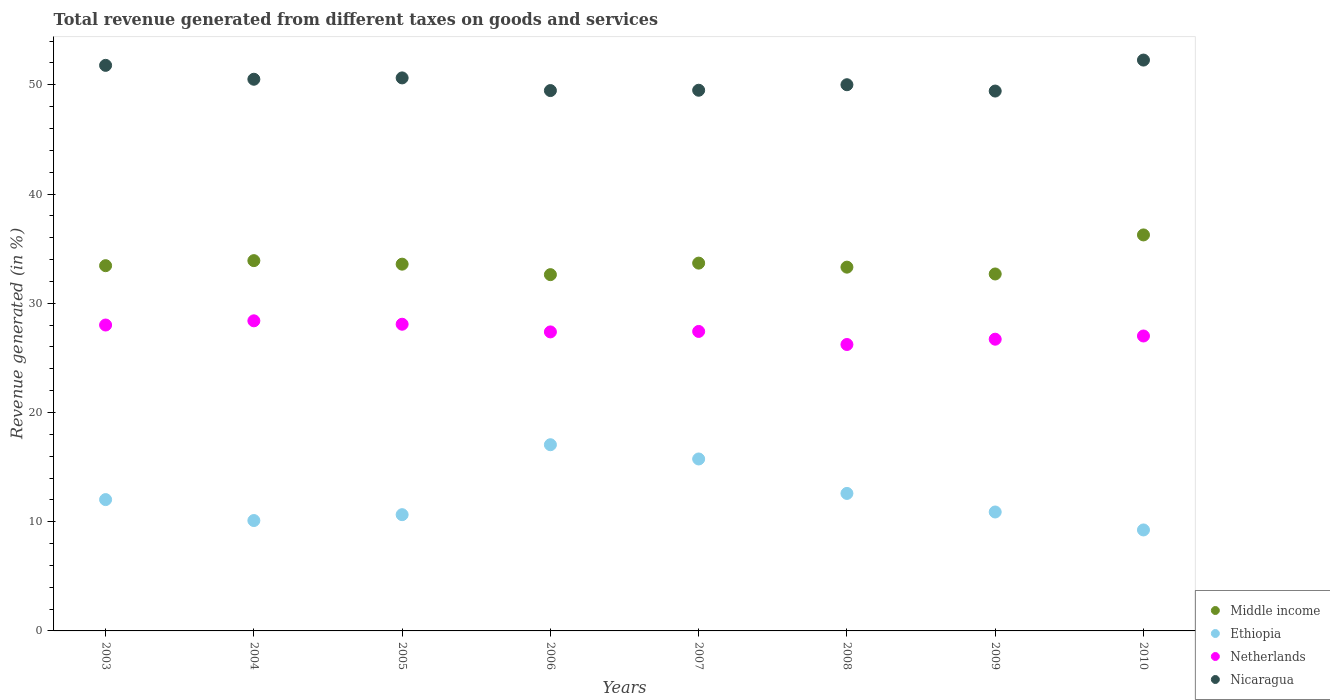Is the number of dotlines equal to the number of legend labels?
Your response must be concise. Yes. What is the total revenue generated in Middle income in 2006?
Your response must be concise. 32.62. Across all years, what is the maximum total revenue generated in Netherlands?
Make the answer very short. 28.39. Across all years, what is the minimum total revenue generated in Middle income?
Keep it short and to the point. 32.62. What is the total total revenue generated in Ethiopia in the graph?
Provide a succinct answer. 98.29. What is the difference between the total revenue generated in Ethiopia in 2003 and that in 2007?
Ensure brevity in your answer.  -3.72. What is the difference between the total revenue generated in Ethiopia in 2003 and the total revenue generated in Netherlands in 2009?
Provide a succinct answer. -14.69. What is the average total revenue generated in Nicaragua per year?
Ensure brevity in your answer.  50.45. In the year 2006, what is the difference between the total revenue generated in Ethiopia and total revenue generated in Middle income?
Offer a terse response. -15.57. What is the ratio of the total revenue generated in Middle income in 2007 to that in 2010?
Your answer should be very brief. 0.93. Is the total revenue generated in Nicaragua in 2004 less than that in 2009?
Provide a succinct answer. No. What is the difference between the highest and the second highest total revenue generated in Ethiopia?
Your response must be concise. 1.3. What is the difference between the highest and the lowest total revenue generated in Ethiopia?
Your answer should be very brief. 7.8. Is it the case that in every year, the sum of the total revenue generated in Ethiopia and total revenue generated in Netherlands  is greater than the sum of total revenue generated in Middle income and total revenue generated in Nicaragua?
Offer a very short reply. No. Is it the case that in every year, the sum of the total revenue generated in Netherlands and total revenue generated in Middle income  is greater than the total revenue generated in Ethiopia?
Make the answer very short. Yes. Is the total revenue generated in Ethiopia strictly greater than the total revenue generated in Middle income over the years?
Provide a short and direct response. No. How many dotlines are there?
Your response must be concise. 4. What is the difference between two consecutive major ticks on the Y-axis?
Give a very brief answer. 10. Does the graph contain any zero values?
Make the answer very short. No. Does the graph contain grids?
Provide a short and direct response. No. Where does the legend appear in the graph?
Offer a very short reply. Bottom right. How many legend labels are there?
Offer a terse response. 4. How are the legend labels stacked?
Offer a terse response. Vertical. What is the title of the graph?
Give a very brief answer. Total revenue generated from different taxes on goods and services. Does "Rwanda" appear as one of the legend labels in the graph?
Offer a very short reply. No. What is the label or title of the X-axis?
Your answer should be very brief. Years. What is the label or title of the Y-axis?
Your answer should be compact. Revenue generated (in %). What is the Revenue generated (in %) of Middle income in 2003?
Keep it short and to the point. 33.44. What is the Revenue generated (in %) of Ethiopia in 2003?
Give a very brief answer. 12.02. What is the Revenue generated (in %) of Netherlands in 2003?
Keep it short and to the point. 28.01. What is the Revenue generated (in %) of Nicaragua in 2003?
Your answer should be compact. 51.78. What is the Revenue generated (in %) in Middle income in 2004?
Make the answer very short. 33.9. What is the Revenue generated (in %) in Ethiopia in 2004?
Provide a short and direct response. 10.11. What is the Revenue generated (in %) of Netherlands in 2004?
Your answer should be compact. 28.39. What is the Revenue generated (in %) of Nicaragua in 2004?
Keep it short and to the point. 50.51. What is the Revenue generated (in %) in Middle income in 2005?
Your answer should be compact. 33.58. What is the Revenue generated (in %) of Ethiopia in 2005?
Offer a very short reply. 10.64. What is the Revenue generated (in %) of Netherlands in 2005?
Ensure brevity in your answer.  28.08. What is the Revenue generated (in %) in Nicaragua in 2005?
Offer a terse response. 50.63. What is the Revenue generated (in %) of Middle income in 2006?
Keep it short and to the point. 32.62. What is the Revenue generated (in %) of Ethiopia in 2006?
Your answer should be compact. 17.05. What is the Revenue generated (in %) of Netherlands in 2006?
Your response must be concise. 27.38. What is the Revenue generated (in %) in Nicaragua in 2006?
Give a very brief answer. 49.47. What is the Revenue generated (in %) of Middle income in 2007?
Your answer should be very brief. 33.68. What is the Revenue generated (in %) of Ethiopia in 2007?
Provide a short and direct response. 15.74. What is the Revenue generated (in %) in Netherlands in 2007?
Offer a terse response. 27.42. What is the Revenue generated (in %) of Nicaragua in 2007?
Provide a short and direct response. 49.5. What is the Revenue generated (in %) in Middle income in 2008?
Provide a short and direct response. 33.31. What is the Revenue generated (in %) of Ethiopia in 2008?
Keep it short and to the point. 12.59. What is the Revenue generated (in %) in Netherlands in 2008?
Make the answer very short. 26.22. What is the Revenue generated (in %) of Nicaragua in 2008?
Your response must be concise. 50.01. What is the Revenue generated (in %) of Middle income in 2009?
Offer a terse response. 32.68. What is the Revenue generated (in %) of Ethiopia in 2009?
Provide a succinct answer. 10.89. What is the Revenue generated (in %) of Netherlands in 2009?
Keep it short and to the point. 26.71. What is the Revenue generated (in %) in Nicaragua in 2009?
Keep it short and to the point. 49.43. What is the Revenue generated (in %) in Middle income in 2010?
Offer a terse response. 36.26. What is the Revenue generated (in %) in Ethiopia in 2010?
Your answer should be very brief. 9.25. What is the Revenue generated (in %) of Netherlands in 2010?
Your answer should be compact. 27. What is the Revenue generated (in %) of Nicaragua in 2010?
Provide a short and direct response. 52.27. Across all years, what is the maximum Revenue generated (in %) in Middle income?
Ensure brevity in your answer.  36.26. Across all years, what is the maximum Revenue generated (in %) in Ethiopia?
Your answer should be compact. 17.05. Across all years, what is the maximum Revenue generated (in %) in Netherlands?
Your response must be concise. 28.39. Across all years, what is the maximum Revenue generated (in %) in Nicaragua?
Keep it short and to the point. 52.27. Across all years, what is the minimum Revenue generated (in %) of Middle income?
Offer a terse response. 32.62. Across all years, what is the minimum Revenue generated (in %) in Ethiopia?
Keep it short and to the point. 9.25. Across all years, what is the minimum Revenue generated (in %) in Netherlands?
Your response must be concise. 26.22. Across all years, what is the minimum Revenue generated (in %) in Nicaragua?
Offer a terse response. 49.43. What is the total Revenue generated (in %) of Middle income in the graph?
Give a very brief answer. 269.47. What is the total Revenue generated (in %) in Ethiopia in the graph?
Your response must be concise. 98.29. What is the total Revenue generated (in %) of Netherlands in the graph?
Ensure brevity in your answer.  219.22. What is the total Revenue generated (in %) in Nicaragua in the graph?
Give a very brief answer. 403.61. What is the difference between the Revenue generated (in %) in Middle income in 2003 and that in 2004?
Your answer should be compact. -0.46. What is the difference between the Revenue generated (in %) of Ethiopia in 2003 and that in 2004?
Offer a terse response. 1.92. What is the difference between the Revenue generated (in %) in Netherlands in 2003 and that in 2004?
Provide a succinct answer. -0.39. What is the difference between the Revenue generated (in %) in Nicaragua in 2003 and that in 2004?
Give a very brief answer. 1.27. What is the difference between the Revenue generated (in %) of Middle income in 2003 and that in 2005?
Provide a succinct answer. -0.14. What is the difference between the Revenue generated (in %) of Ethiopia in 2003 and that in 2005?
Make the answer very short. 1.38. What is the difference between the Revenue generated (in %) in Netherlands in 2003 and that in 2005?
Your answer should be very brief. -0.07. What is the difference between the Revenue generated (in %) of Nicaragua in 2003 and that in 2005?
Your response must be concise. 1.15. What is the difference between the Revenue generated (in %) of Middle income in 2003 and that in 2006?
Ensure brevity in your answer.  0.82. What is the difference between the Revenue generated (in %) in Ethiopia in 2003 and that in 2006?
Give a very brief answer. -5.02. What is the difference between the Revenue generated (in %) of Netherlands in 2003 and that in 2006?
Offer a terse response. 0.63. What is the difference between the Revenue generated (in %) in Nicaragua in 2003 and that in 2006?
Give a very brief answer. 2.31. What is the difference between the Revenue generated (in %) in Middle income in 2003 and that in 2007?
Your response must be concise. -0.23. What is the difference between the Revenue generated (in %) in Ethiopia in 2003 and that in 2007?
Keep it short and to the point. -3.72. What is the difference between the Revenue generated (in %) of Netherlands in 2003 and that in 2007?
Your answer should be very brief. 0.59. What is the difference between the Revenue generated (in %) of Nicaragua in 2003 and that in 2007?
Keep it short and to the point. 2.28. What is the difference between the Revenue generated (in %) of Middle income in 2003 and that in 2008?
Make the answer very short. 0.13. What is the difference between the Revenue generated (in %) in Ethiopia in 2003 and that in 2008?
Offer a very short reply. -0.57. What is the difference between the Revenue generated (in %) of Netherlands in 2003 and that in 2008?
Your answer should be very brief. 1.78. What is the difference between the Revenue generated (in %) in Nicaragua in 2003 and that in 2008?
Offer a very short reply. 1.77. What is the difference between the Revenue generated (in %) in Middle income in 2003 and that in 2009?
Make the answer very short. 0.76. What is the difference between the Revenue generated (in %) of Ethiopia in 2003 and that in 2009?
Make the answer very short. 1.13. What is the difference between the Revenue generated (in %) of Netherlands in 2003 and that in 2009?
Offer a very short reply. 1.3. What is the difference between the Revenue generated (in %) of Nicaragua in 2003 and that in 2009?
Provide a short and direct response. 2.35. What is the difference between the Revenue generated (in %) of Middle income in 2003 and that in 2010?
Keep it short and to the point. -2.82. What is the difference between the Revenue generated (in %) in Ethiopia in 2003 and that in 2010?
Offer a terse response. 2.78. What is the difference between the Revenue generated (in %) of Netherlands in 2003 and that in 2010?
Give a very brief answer. 1. What is the difference between the Revenue generated (in %) of Nicaragua in 2003 and that in 2010?
Your answer should be compact. -0.48. What is the difference between the Revenue generated (in %) in Middle income in 2004 and that in 2005?
Offer a very short reply. 0.32. What is the difference between the Revenue generated (in %) of Ethiopia in 2004 and that in 2005?
Your response must be concise. -0.54. What is the difference between the Revenue generated (in %) of Netherlands in 2004 and that in 2005?
Ensure brevity in your answer.  0.31. What is the difference between the Revenue generated (in %) in Nicaragua in 2004 and that in 2005?
Make the answer very short. -0.12. What is the difference between the Revenue generated (in %) of Middle income in 2004 and that in 2006?
Offer a very short reply. 1.28. What is the difference between the Revenue generated (in %) of Ethiopia in 2004 and that in 2006?
Offer a very short reply. -6.94. What is the difference between the Revenue generated (in %) in Netherlands in 2004 and that in 2006?
Provide a succinct answer. 1.02. What is the difference between the Revenue generated (in %) in Nicaragua in 2004 and that in 2006?
Your answer should be very brief. 1.04. What is the difference between the Revenue generated (in %) in Middle income in 2004 and that in 2007?
Your response must be concise. 0.23. What is the difference between the Revenue generated (in %) of Ethiopia in 2004 and that in 2007?
Ensure brevity in your answer.  -5.64. What is the difference between the Revenue generated (in %) in Netherlands in 2004 and that in 2007?
Give a very brief answer. 0.97. What is the difference between the Revenue generated (in %) in Middle income in 2004 and that in 2008?
Offer a very short reply. 0.6. What is the difference between the Revenue generated (in %) in Ethiopia in 2004 and that in 2008?
Offer a very short reply. -2.48. What is the difference between the Revenue generated (in %) of Netherlands in 2004 and that in 2008?
Your response must be concise. 2.17. What is the difference between the Revenue generated (in %) in Nicaragua in 2004 and that in 2008?
Your answer should be very brief. 0.5. What is the difference between the Revenue generated (in %) of Middle income in 2004 and that in 2009?
Your answer should be very brief. 1.22. What is the difference between the Revenue generated (in %) of Ethiopia in 2004 and that in 2009?
Make the answer very short. -0.78. What is the difference between the Revenue generated (in %) in Netherlands in 2004 and that in 2009?
Ensure brevity in your answer.  1.68. What is the difference between the Revenue generated (in %) in Nicaragua in 2004 and that in 2009?
Your answer should be compact. 1.08. What is the difference between the Revenue generated (in %) in Middle income in 2004 and that in 2010?
Your response must be concise. -2.35. What is the difference between the Revenue generated (in %) of Ethiopia in 2004 and that in 2010?
Make the answer very short. 0.86. What is the difference between the Revenue generated (in %) of Netherlands in 2004 and that in 2010?
Provide a short and direct response. 1.39. What is the difference between the Revenue generated (in %) in Nicaragua in 2004 and that in 2010?
Give a very brief answer. -1.76. What is the difference between the Revenue generated (in %) in Middle income in 2005 and that in 2006?
Your answer should be compact. 0.96. What is the difference between the Revenue generated (in %) in Ethiopia in 2005 and that in 2006?
Offer a terse response. -6.4. What is the difference between the Revenue generated (in %) in Netherlands in 2005 and that in 2006?
Make the answer very short. 0.7. What is the difference between the Revenue generated (in %) in Nicaragua in 2005 and that in 2006?
Ensure brevity in your answer.  1.16. What is the difference between the Revenue generated (in %) of Middle income in 2005 and that in 2007?
Your response must be concise. -0.1. What is the difference between the Revenue generated (in %) of Ethiopia in 2005 and that in 2007?
Your answer should be very brief. -5.1. What is the difference between the Revenue generated (in %) in Netherlands in 2005 and that in 2007?
Offer a very short reply. 0.66. What is the difference between the Revenue generated (in %) in Nicaragua in 2005 and that in 2007?
Provide a succinct answer. 1.13. What is the difference between the Revenue generated (in %) of Middle income in 2005 and that in 2008?
Your response must be concise. 0.27. What is the difference between the Revenue generated (in %) of Ethiopia in 2005 and that in 2008?
Keep it short and to the point. -1.95. What is the difference between the Revenue generated (in %) of Netherlands in 2005 and that in 2008?
Provide a succinct answer. 1.86. What is the difference between the Revenue generated (in %) in Nicaragua in 2005 and that in 2008?
Your response must be concise. 0.62. What is the difference between the Revenue generated (in %) of Middle income in 2005 and that in 2009?
Offer a terse response. 0.9. What is the difference between the Revenue generated (in %) of Ethiopia in 2005 and that in 2009?
Your answer should be compact. -0.25. What is the difference between the Revenue generated (in %) in Netherlands in 2005 and that in 2009?
Give a very brief answer. 1.37. What is the difference between the Revenue generated (in %) of Nicaragua in 2005 and that in 2009?
Ensure brevity in your answer.  1.2. What is the difference between the Revenue generated (in %) in Middle income in 2005 and that in 2010?
Keep it short and to the point. -2.68. What is the difference between the Revenue generated (in %) in Ethiopia in 2005 and that in 2010?
Ensure brevity in your answer.  1.4. What is the difference between the Revenue generated (in %) of Netherlands in 2005 and that in 2010?
Provide a succinct answer. 1.08. What is the difference between the Revenue generated (in %) in Nicaragua in 2005 and that in 2010?
Your response must be concise. -1.63. What is the difference between the Revenue generated (in %) of Middle income in 2006 and that in 2007?
Offer a terse response. -1.06. What is the difference between the Revenue generated (in %) in Ethiopia in 2006 and that in 2007?
Provide a succinct answer. 1.3. What is the difference between the Revenue generated (in %) in Netherlands in 2006 and that in 2007?
Offer a very short reply. -0.04. What is the difference between the Revenue generated (in %) of Nicaragua in 2006 and that in 2007?
Give a very brief answer. -0.03. What is the difference between the Revenue generated (in %) in Middle income in 2006 and that in 2008?
Provide a succinct answer. -0.69. What is the difference between the Revenue generated (in %) of Ethiopia in 2006 and that in 2008?
Make the answer very short. 4.46. What is the difference between the Revenue generated (in %) of Netherlands in 2006 and that in 2008?
Your answer should be compact. 1.15. What is the difference between the Revenue generated (in %) of Nicaragua in 2006 and that in 2008?
Keep it short and to the point. -0.54. What is the difference between the Revenue generated (in %) in Middle income in 2006 and that in 2009?
Your response must be concise. -0.06. What is the difference between the Revenue generated (in %) in Ethiopia in 2006 and that in 2009?
Give a very brief answer. 6.16. What is the difference between the Revenue generated (in %) in Netherlands in 2006 and that in 2009?
Your answer should be compact. 0.67. What is the difference between the Revenue generated (in %) in Nicaragua in 2006 and that in 2009?
Offer a very short reply. 0.04. What is the difference between the Revenue generated (in %) of Middle income in 2006 and that in 2010?
Offer a very short reply. -3.64. What is the difference between the Revenue generated (in %) of Ethiopia in 2006 and that in 2010?
Provide a succinct answer. 7.8. What is the difference between the Revenue generated (in %) in Netherlands in 2006 and that in 2010?
Make the answer very short. 0.37. What is the difference between the Revenue generated (in %) of Nicaragua in 2006 and that in 2010?
Keep it short and to the point. -2.79. What is the difference between the Revenue generated (in %) in Middle income in 2007 and that in 2008?
Offer a very short reply. 0.37. What is the difference between the Revenue generated (in %) in Ethiopia in 2007 and that in 2008?
Your response must be concise. 3.15. What is the difference between the Revenue generated (in %) of Netherlands in 2007 and that in 2008?
Offer a very short reply. 1.2. What is the difference between the Revenue generated (in %) of Nicaragua in 2007 and that in 2008?
Give a very brief answer. -0.51. What is the difference between the Revenue generated (in %) in Middle income in 2007 and that in 2009?
Ensure brevity in your answer.  0.99. What is the difference between the Revenue generated (in %) in Ethiopia in 2007 and that in 2009?
Provide a succinct answer. 4.85. What is the difference between the Revenue generated (in %) in Netherlands in 2007 and that in 2009?
Provide a short and direct response. 0.71. What is the difference between the Revenue generated (in %) of Nicaragua in 2007 and that in 2009?
Your answer should be compact. 0.07. What is the difference between the Revenue generated (in %) in Middle income in 2007 and that in 2010?
Offer a very short reply. -2.58. What is the difference between the Revenue generated (in %) of Ethiopia in 2007 and that in 2010?
Provide a succinct answer. 6.5. What is the difference between the Revenue generated (in %) in Netherlands in 2007 and that in 2010?
Offer a terse response. 0.42. What is the difference between the Revenue generated (in %) of Nicaragua in 2007 and that in 2010?
Provide a succinct answer. -2.76. What is the difference between the Revenue generated (in %) of Middle income in 2008 and that in 2009?
Offer a very short reply. 0.63. What is the difference between the Revenue generated (in %) of Ethiopia in 2008 and that in 2009?
Offer a very short reply. 1.7. What is the difference between the Revenue generated (in %) of Netherlands in 2008 and that in 2009?
Keep it short and to the point. -0.49. What is the difference between the Revenue generated (in %) in Nicaragua in 2008 and that in 2009?
Your answer should be compact. 0.58. What is the difference between the Revenue generated (in %) of Middle income in 2008 and that in 2010?
Ensure brevity in your answer.  -2.95. What is the difference between the Revenue generated (in %) of Ethiopia in 2008 and that in 2010?
Offer a terse response. 3.34. What is the difference between the Revenue generated (in %) of Netherlands in 2008 and that in 2010?
Ensure brevity in your answer.  -0.78. What is the difference between the Revenue generated (in %) in Nicaragua in 2008 and that in 2010?
Offer a very short reply. -2.26. What is the difference between the Revenue generated (in %) in Middle income in 2009 and that in 2010?
Keep it short and to the point. -3.58. What is the difference between the Revenue generated (in %) of Ethiopia in 2009 and that in 2010?
Offer a very short reply. 1.64. What is the difference between the Revenue generated (in %) of Netherlands in 2009 and that in 2010?
Make the answer very short. -0.29. What is the difference between the Revenue generated (in %) of Nicaragua in 2009 and that in 2010?
Provide a short and direct response. -2.84. What is the difference between the Revenue generated (in %) of Middle income in 2003 and the Revenue generated (in %) of Ethiopia in 2004?
Provide a succinct answer. 23.34. What is the difference between the Revenue generated (in %) of Middle income in 2003 and the Revenue generated (in %) of Netherlands in 2004?
Offer a terse response. 5.05. What is the difference between the Revenue generated (in %) in Middle income in 2003 and the Revenue generated (in %) in Nicaragua in 2004?
Offer a terse response. -17.07. What is the difference between the Revenue generated (in %) of Ethiopia in 2003 and the Revenue generated (in %) of Netherlands in 2004?
Offer a very short reply. -16.37. What is the difference between the Revenue generated (in %) in Ethiopia in 2003 and the Revenue generated (in %) in Nicaragua in 2004?
Keep it short and to the point. -38.49. What is the difference between the Revenue generated (in %) in Netherlands in 2003 and the Revenue generated (in %) in Nicaragua in 2004?
Offer a terse response. -22.5. What is the difference between the Revenue generated (in %) of Middle income in 2003 and the Revenue generated (in %) of Ethiopia in 2005?
Make the answer very short. 22.8. What is the difference between the Revenue generated (in %) of Middle income in 2003 and the Revenue generated (in %) of Netherlands in 2005?
Give a very brief answer. 5.36. What is the difference between the Revenue generated (in %) in Middle income in 2003 and the Revenue generated (in %) in Nicaragua in 2005?
Provide a succinct answer. -17.19. What is the difference between the Revenue generated (in %) in Ethiopia in 2003 and the Revenue generated (in %) in Netherlands in 2005?
Provide a succinct answer. -16.06. What is the difference between the Revenue generated (in %) in Ethiopia in 2003 and the Revenue generated (in %) in Nicaragua in 2005?
Make the answer very short. -38.61. What is the difference between the Revenue generated (in %) of Netherlands in 2003 and the Revenue generated (in %) of Nicaragua in 2005?
Offer a terse response. -22.63. What is the difference between the Revenue generated (in %) of Middle income in 2003 and the Revenue generated (in %) of Ethiopia in 2006?
Keep it short and to the point. 16.39. What is the difference between the Revenue generated (in %) in Middle income in 2003 and the Revenue generated (in %) in Netherlands in 2006?
Your response must be concise. 6.06. What is the difference between the Revenue generated (in %) in Middle income in 2003 and the Revenue generated (in %) in Nicaragua in 2006?
Give a very brief answer. -16.03. What is the difference between the Revenue generated (in %) of Ethiopia in 2003 and the Revenue generated (in %) of Netherlands in 2006?
Keep it short and to the point. -15.35. What is the difference between the Revenue generated (in %) in Ethiopia in 2003 and the Revenue generated (in %) in Nicaragua in 2006?
Offer a very short reply. -37.45. What is the difference between the Revenue generated (in %) in Netherlands in 2003 and the Revenue generated (in %) in Nicaragua in 2006?
Offer a very short reply. -21.47. What is the difference between the Revenue generated (in %) in Middle income in 2003 and the Revenue generated (in %) in Ethiopia in 2007?
Your response must be concise. 17.7. What is the difference between the Revenue generated (in %) of Middle income in 2003 and the Revenue generated (in %) of Netherlands in 2007?
Make the answer very short. 6.02. What is the difference between the Revenue generated (in %) of Middle income in 2003 and the Revenue generated (in %) of Nicaragua in 2007?
Your answer should be very brief. -16.06. What is the difference between the Revenue generated (in %) of Ethiopia in 2003 and the Revenue generated (in %) of Netherlands in 2007?
Provide a short and direct response. -15.4. What is the difference between the Revenue generated (in %) of Ethiopia in 2003 and the Revenue generated (in %) of Nicaragua in 2007?
Offer a very short reply. -37.48. What is the difference between the Revenue generated (in %) in Netherlands in 2003 and the Revenue generated (in %) in Nicaragua in 2007?
Give a very brief answer. -21.5. What is the difference between the Revenue generated (in %) in Middle income in 2003 and the Revenue generated (in %) in Ethiopia in 2008?
Keep it short and to the point. 20.85. What is the difference between the Revenue generated (in %) in Middle income in 2003 and the Revenue generated (in %) in Netherlands in 2008?
Make the answer very short. 7.22. What is the difference between the Revenue generated (in %) in Middle income in 2003 and the Revenue generated (in %) in Nicaragua in 2008?
Offer a terse response. -16.57. What is the difference between the Revenue generated (in %) of Ethiopia in 2003 and the Revenue generated (in %) of Netherlands in 2008?
Provide a succinct answer. -14.2. What is the difference between the Revenue generated (in %) in Ethiopia in 2003 and the Revenue generated (in %) in Nicaragua in 2008?
Offer a terse response. -37.99. What is the difference between the Revenue generated (in %) of Netherlands in 2003 and the Revenue generated (in %) of Nicaragua in 2008?
Offer a very short reply. -22. What is the difference between the Revenue generated (in %) of Middle income in 2003 and the Revenue generated (in %) of Ethiopia in 2009?
Offer a very short reply. 22.55. What is the difference between the Revenue generated (in %) of Middle income in 2003 and the Revenue generated (in %) of Netherlands in 2009?
Ensure brevity in your answer.  6.73. What is the difference between the Revenue generated (in %) in Middle income in 2003 and the Revenue generated (in %) in Nicaragua in 2009?
Provide a short and direct response. -15.99. What is the difference between the Revenue generated (in %) in Ethiopia in 2003 and the Revenue generated (in %) in Netherlands in 2009?
Make the answer very short. -14.69. What is the difference between the Revenue generated (in %) of Ethiopia in 2003 and the Revenue generated (in %) of Nicaragua in 2009?
Your answer should be very brief. -37.41. What is the difference between the Revenue generated (in %) of Netherlands in 2003 and the Revenue generated (in %) of Nicaragua in 2009?
Your answer should be very brief. -21.42. What is the difference between the Revenue generated (in %) of Middle income in 2003 and the Revenue generated (in %) of Ethiopia in 2010?
Keep it short and to the point. 24.2. What is the difference between the Revenue generated (in %) of Middle income in 2003 and the Revenue generated (in %) of Netherlands in 2010?
Offer a terse response. 6.44. What is the difference between the Revenue generated (in %) in Middle income in 2003 and the Revenue generated (in %) in Nicaragua in 2010?
Give a very brief answer. -18.83. What is the difference between the Revenue generated (in %) of Ethiopia in 2003 and the Revenue generated (in %) of Netherlands in 2010?
Provide a short and direct response. -14.98. What is the difference between the Revenue generated (in %) in Ethiopia in 2003 and the Revenue generated (in %) in Nicaragua in 2010?
Your response must be concise. -40.24. What is the difference between the Revenue generated (in %) of Netherlands in 2003 and the Revenue generated (in %) of Nicaragua in 2010?
Make the answer very short. -24.26. What is the difference between the Revenue generated (in %) of Middle income in 2004 and the Revenue generated (in %) of Ethiopia in 2005?
Provide a short and direct response. 23.26. What is the difference between the Revenue generated (in %) in Middle income in 2004 and the Revenue generated (in %) in Netherlands in 2005?
Provide a short and direct response. 5.82. What is the difference between the Revenue generated (in %) of Middle income in 2004 and the Revenue generated (in %) of Nicaragua in 2005?
Your response must be concise. -16.73. What is the difference between the Revenue generated (in %) of Ethiopia in 2004 and the Revenue generated (in %) of Netherlands in 2005?
Your answer should be compact. -17.97. What is the difference between the Revenue generated (in %) in Ethiopia in 2004 and the Revenue generated (in %) in Nicaragua in 2005?
Make the answer very short. -40.53. What is the difference between the Revenue generated (in %) of Netherlands in 2004 and the Revenue generated (in %) of Nicaragua in 2005?
Keep it short and to the point. -22.24. What is the difference between the Revenue generated (in %) in Middle income in 2004 and the Revenue generated (in %) in Ethiopia in 2006?
Provide a short and direct response. 16.86. What is the difference between the Revenue generated (in %) of Middle income in 2004 and the Revenue generated (in %) of Netherlands in 2006?
Keep it short and to the point. 6.53. What is the difference between the Revenue generated (in %) of Middle income in 2004 and the Revenue generated (in %) of Nicaragua in 2006?
Provide a succinct answer. -15.57. What is the difference between the Revenue generated (in %) in Ethiopia in 2004 and the Revenue generated (in %) in Netherlands in 2006?
Offer a very short reply. -17.27. What is the difference between the Revenue generated (in %) in Ethiopia in 2004 and the Revenue generated (in %) in Nicaragua in 2006?
Ensure brevity in your answer.  -39.37. What is the difference between the Revenue generated (in %) in Netherlands in 2004 and the Revenue generated (in %) in Nicaragua in 2006?
Your response must be concise. -21.08. What is the difference between the Revenue generated (in %) in Middle income in 2004 and the Revenue generated (in %) in Ethiopia in 2007?
Offer a very short reply. 18.16. What is the difference between the Revenue generated (in %) in Middle income in 2004 and the Revenue generated (in %) in Netherlands in 2007?
Offer a very short reply. 6.48. What is the difference between the Revenue generated (in %) in Middle income in 2004 and the Revenue generated (in %) in Nicaragua in 2007?
Make the answer very short. -15.6. What is the difference between the Revenue generated (in %) in Ethiopia in 2004 and the Revenue generated (in %) in Netherlands in 2007?
Keep it short and to the point. -17.31. What is the difference between the Revenue generated (in %) in Ethiopia in 2004 and the Revenue generated (in %) in Nicaragua in 2007?
Offer a terse response. -39.4. What is the difference between the Revenue generated (in %) in Netherlands in 2004 and the Revenue generated (in %) in Nicaragua in 2007?
Provide a short and direct response. -21.11. What is the difference between the Revenue generated (in %) in Middle income in 2004 and the Revenue generated (in %) in Ethiopia in 2008?
Offer a very short reply. 21.31. What is the difference between the Revenue generated (in %) in Middle income in 2004 and the Revenue generated (in %) in Netherlands in 2008?
Make the answer very short. 7.68. What is the difference between the Revenue generated (in %) of Middle income in 2004 and the Revenue generated (in %) of Nicaragua in 2008?
Your answer should be compact. -16.11. What is the difference between the Revenue generated (in %) of Ethiopia in 2004 and the Revenue generated (in %) of Netherlands in 2008?
Your answer should be compact. -16.12. What is the difference between the Revenue generated (in %) in Ethiopia in 2004 and the Revenue generated (in %) in Nicaragua in 2008?
Provide a succinct answer. -39.9. What is the difference between the Revenue generated (in %) in Netherlands in 2004 and the Revenue generated (in %) in Nicaragua in 2008?
Offer a terse response. -21.62. What is the difference between the Revenue generated (in %) in Middle income in 2004 and the Revenue generated (in %) in Ethiopia in 2009?
Make the answer very short. 23.01. What is the difference between the Revenue generated (in %) of Middle income in 2004 and the Revenue generated (in %) of Netherlands in 2009?
Offer a terse response. 7.19. What is the difference between the Revenue generated (in %) of Middle income in 2004 and the Revenue generated (in %) of Nicaragua in 2009?
Ensure brevity in your answer.  -15.53. What is the difference between the Revenue generated (in %) of Ethiopia in 2004 and the Revenue generated (in %) of Netherlands in 2009?
Your answer should be very brief. -16.6. What is the difference between the Revenue generated (in %) in Ethiopia in 2004 and the Revenue generated (in %) in Nicaragua in 2009?
Make the answer very short. -39.32. What is the difference between the Revenue generated (in %) in Netherlands in 2004 and the Revenue generated (in %) in Nicaragua in 2009?
Make the answer very short. -21.04. What is the difference between the Revenue generated (in %) of Middle income in 2004 and the Revenue generated (in %) of Ethiopia in 2010?
Give a very brief answer. 24.66. What is the difference between the Revenue generated (in %) in Middle income in 2004 and the Revenue generated (in %) in Netherlands in 2010?
Ensure brevity in your answer.  6.9. What is the difference between the Revenue generated (in %) in Middle income in 2004 and the Revenue generated (in %) in Nicaragua in 2010?
Keep it short and to the point. -18.36. What is the difference between the Revenue generated (in %) of Ethiopia in 2004 and the Revenue generated (in %) of Netherlands in 2010?
Your answer should be very brief. -16.9. What is the difference between the Revenue generated (in %) in Ethiopia in 2004 and the Revenue generated (in %) in Nicaragua in 2010?
Your response must be concise. -42.16. What is the difference between the Revenue generated (in %) in Netherlands in 2004 and the Revenue generated (in %) in Nicaragua in 2010?
Provide a short and direct response. -23.87. What is the difference between the Revenue generated (in %) of Middle income in 2005 and the Revenue generated (in %) of Ethiopia in 2006?
Provide a succinct answer. 16.53. What is the difference between the Revenue generated (in %) of Middle income in 2005 and the Revenue generated (in %) of Netherlands in 2006?
Provide a short and direct response. 6.2. What is the difference between the Revenue generated (in %) in Middle income in 2005 and the Revenue generated (in %) in Nicaragua in 2006?
Offer a terse response. -15.89. What is the difference between the Revenue generated (in %) in Ethiopia in 2005 and the Revenue generated (in %) in Netherlands in 2006?
Your answer should be very brief. -16.73. What is the difference between the Revenue generated (in %) in Ethiopia in 2005 and the Revenue generated (in %) in Nicaragua in 2006?
Give a very brief answer. -38.83. What is the difference between the Revenue generated (in %) of Netherlands in 2005 and the Revenue generated (in %) of Nicaragua in 2006?
Provide a short and direct response. -21.39. What is the difference between the Revenue generated (in %) of Middle income in 2005 and the Revenue generated (in %) of Ethiopia in 2007?
Your answer should be compact. 17.84. What is the difference between the Revenue generated (in %) in Middle income in 2005 and the Revenue generated (in %) in Netherlands in 2007?
Keep it short and to the point. 6.16. What is the difference between the Revenue generated (in %) in Middle income in 2005 and the Revenue generated (in %) in Nicaragua in 2007?
Your answer should be compact. -15.92. What is the difference between the Revenue generated (in %) in Ethiopia in 2005 and the Revenue generated (in %) in Netherlands in 2007?
Your answer should be very brief. -16.78. What is the difference between the Revenue generated (in %) of Ethiopia in 2005 and the Revenue generated (in %) of Nicaragua in 2007?
Give a very brief answer. -38.86. What is the difference between the Revenue generated (in %) in Netherlands in 2005 and the Revenue generated (in %) in Nicaragua in 2007?
Your answer should be very brief. -21.42. What is the difference between the Revenue generated (in %) of Middle income in 2005 and the Revenue generated (in %) of Ethiopia in 2008?
Provide a short and direct response. 20.99. What is the difference between the Revenue generated (in %) in Middle income in 2005 and the Revenue generated (in %) in Netherlands in 2008?
Offer a terse response. 7.36. What is the difference between the Revenue generated (in %) of Middle income in 2005 and the Revenue generated (in %) of Nicaragua in 2008?
Your answer should be compact. -16.43. What is the difference between the Revenue generated (in %) of Ethiopia in 2005 and the Revenue generated (in %) of Netherlands in 2008?
Offer a terse response. -15.58. What is the difference between the Revenue generated (in %) in Ethiopia in 2005 and the Revenue generated (in %) in Nicaragua in 2008?
Ensure brevity in your answer.  -39.37. What is the difference between the Revenue generated (in %) of Netherlands in 2005 and the Revenue generated (in %) of Nicaragua in 2008?
Your answer should be very brief. -21.93. What is the difference between the Revenue generated (in %) of Middle income in 2005 and the Revenue generated (in %) of Ethiopia in 2009?
Your response must be concise. 22.69. What is the difference between the Revenue generated (in %) in Middle income in 2005 and the Revenue generated (in %) in Netherlands in 2009?
Provide a short and direct response. 6.87. What is the difference between the Revenue generated (in %) of Middle income in 2005 and the Revenue generated (in %) of Nicaragua in 2009?
Your answer should be very brief. -15.85. What is the difference between the Revenue generated (in %) in Ethiopia in 2005 and the Revenue generated (in %) in Netherlands in 2009?
Your response must be concise. -16.07. What is the difference between the Revenue generated (in %) in Ethiopia in 2005 and the Revenue generated (in %) in Nicaragua in 2009?
Provide a succinct answer. -38.79. What is the difference between the Revenue generated (in %) of Netherlands in 2005 and the Revenue generated (in %) of Nicaragua in 2009?
Ensure brevity in your answer.  -21.35. What is the difference between the Revenue generated (in %) of Middle income in 2005 and the Revenue generated (in %) of Ethiopia in 2010?
Your response must be concise. 24.33. What is the difference between the Revenue generated (in %) of Middle income in 2005 and the Revenue generated (in %) of Netherlands in 2010?
Your answer should be very brief. 6.58. What is the difference between the Revenue generated (in %) of Middle income in 2005 and the Revenue generated (in %) of Nicaragua in 2010?
Give a very brief answer. -18.69. What is the difference between the Revenue generated (in %) of Ethiopia in 2005 and the Revenue generated (in %) of Netherlands in 2010?
Your answer should be very brief. -16.36. What is the difference between the Revenue generated (in %) in Ethiopia in 2005 and the Revenue generated (in %) in Nicaragua in 2010?
Your response must be concise. -41.62. What is the difference between the Revenue generated (in %) in Netherlands in 2005 and the Revenue generated (in %) in Nicaragua in 2010?
Give a very brief answer. -24.19. What is the difference between the Revenue generated (in %) in Middle income in 2006 and the Revenue generated (in %) in Ethiopia in 2007?
Keep it short and to the point. 16.88. What is the difference between the Revenue generated (in %) in Middle income in 2006 and the Revenue generated (in %) in Netherlands in 2007?
Provide a short and direct response. 5.2. What is the difference between the Revenue generated (in %) of Middle income in 2006 and the Revenue generated (in %) of Nicaragua in 2007?
Provide a short and direct response. -16.88. What is the difference between the Revenue generated (in %) of Ethiopia in 2006 and the Revenue generated (in %) of Netherlands in 2007?
Make the answer very short. -10.37. What is the difference between the Revenue generated (in %) of Ethiopia in 2006 and the Revenue generated (in %) of Nicaragua in 2007?
Your answer should be compact. -32.46. What is the difference between the Revenue generated (in %) of Netherlands in 2006 and the Revenue generated (in %) of Nicaragua in 2007?
Your answer should be very brief. -22.13. What is the difference between the Revenue generated (in %) in Middle income in 2006 and the Revenue generated (in %) in Ethiopia in 2008?
Your answer should be compact. 20.03. What is the difference between the Revenue generated (in %) in Middle income in 2006 and the Revenue generated (in %) in Netherlands in 2008?
Ensure brevity in your answer.  6.4. What is the difference between the Revenue generated (in %) in Middle income in 2006 and the Revenue generated (in %) in Nicaragua in 2008?
Keep it short and to the point. -17.39. What is the difference between the Revenue generated (in %) of Ethiopia in 2006 and the Revenue generated (in %) of Netherlands in 2008?
Offer a very short reply. -9.18. What is the difference between the Revenue generated (in %) in Ethiopia in 2006 and the Revenue generated (in %) in Nicaragua in 2008?
Your response must be concise. -32.96. What is the difference between the Revenue generated (in %) of Netherlands in 2006 and the Revenue generated (in %) of Nicaragua in 2008?
Offer a terse response. -22.63. What is the difference between the Revenue generated (in %) in Middle income in 2006 and the Revenue generated (in %) in Ethiopia in 2009?
Provide a short and direct response. 21.73. What is the difference between the Revenue generated (in %) of Middle income in 2006 and the Revenue generated (in %) of Netherlands in 2009?
Your answer should be very brief. 5.91. What is the difference between the Revenue generated (in %) in Middle income in 2006 and the Revenue generated (in %) in Nicaragua in 2009?
Keep it short and to the point. -16.81. What is the difference between the Revenue generated (in %) in Ethiopia in 2006 and the Revenue generated (in %) in Netherlands in 2009?
Give a very brief answer. -9.66. What is the difference between the Revenue generated (in %) in Ethiopia in 2006 and the Revenue generated (in %) in Nicaragua in 2009?
Provide a succinct answer. -32.38. What is the difference between the Revenue generated (in %) in Netherlands in 2006 and the Revenue generated (in %) in Nicaragua in 2009?
Your answer should be compact. -22.05. What is the difference between the Revenue generated (in %) of Middle income in 2006 and the Revenue generated (in %) of Ethiopia in 2010?
Provide a succinct answer. 23.38. What is the difference between the Revenue generated (in %) of Middle income in 2006 and the Revenue generated (in %) of Netherlands in 2010?
Your answer should be compact. 5.62. What is the difference between the Revenue generated (in %) in Middle income in 2006 and the Revenue generated (in %) in Nicaragua in 2010?
Your response must be concise. -19.65. What is the difference between the Revenue generated (in %) of Ethiopia in 2006 and the Revenue generated (in %) of Netherlands in 2010?
Ensure brevity in your answer.  -9.96. What is the difference between the Revenue generated (in %) in Ethiopia in 2006 and the Revenue generated (in %) in Nicaragua in 2010?
Your answer should be compact. -35.22. What is the difference between the Revenue generated (in %) of Netherlands in 2006 and the Revenue generated (in %) of Nicaragua in 2010?
Offer a very short reply. -24.89. What is the difference between the Revenue generated (in %) in Middle income in 2007 and the Revenue generated (in %) in Ethiopia in 2008?
Provide a short and direct response. 21.09. What is the difference between the Revenue generated (in %) in Middle income in 2007 and the Revenue generated (in %) in Netherlands in 2008?
Your response must be concise. 7.45. What is the difference between the Revenue generated (in %) of Middle income in 2007 and the Revenue generated (in %) of Nicaragua in 2008?
Provide a short and direct response. -16.33. What is the difference between the Revenue generated (in %) in Ethiopia in 2007 and the Revenue generated (in %) in Netherlands in 2008?
Your answer should be compact. -10.48. What is the difference between the Revenue generated (in %) of Ethiopia in 2007 and the Revenue generated (in %) of Nicaragua in 2008?
Provide a short and direct response. -34.27. What is the difference between the Revenue generated (in %) in Netherlands in 2007 and the Revenue generated (in %) in Nicaragua in 2008?
Your answer should be compact. -22.59. What is the difference between the Revenue generated (in %) of Middle income in 2007 and the Revenue generated (in %) of Ethiopia in 2009?
Give a very brief answer. 22.79. What is the difference between the Revenue generated (in %) in Middle income in 2007 and the Revenue generated (in %) in Netherlands in 2009?
Keep it short and to the point. 6.97. What is the difference between the Revenue generated (in %) of Middle income in 2007 and the Revenue generated (in %) of Nicaragua in 2009?
Offer a very short reply. -15.75. What is the difference between the Revenue generated (in %) in Ethiopia in 2007 and the Revenue generated (in %) in Netherlands in 2009?
Provide a succinct answer. -10.97. What is the difference between the Revenue generated (in %) in Ethiopia in 2007 and the Revenue generated (in %) in Nicaragua in 2009?
Provide a succinct answer. -33.69. What is the difference between the Revenue generated (in %) in Netherlands in 2007 and the Revenue generated (in %) in Nicaragua in 2009?
Make the answer very short. -22.01. What is the difference between the Revenue generated (in %) of Middle income in 2007 and the Revenue generated (in %) of Ethiopia in 2010?
Keep it short and to the point. 24.43. What is the difference between the Revenue generated (in %) in Middle income in 2007 and the Revenue generated (in %) in Netherlands in 2010?
Offer a terse response. 6.67. What is the difference between the Revenue generated (in %) in Middle income in 2007 and the Revenue generated (in %) in Nicaragua in 2010?
Give a very brief answer. -18.59. What is the difference between the Revenue generated (in %) in Ethiopia in 2007 and the Revenue generated (in %) in Netherlands in 2010?
Your answer should be compact. -11.26. What is the difference between the Revenue generated (in %) of Ethiopia in 2007 and the Revenue generated (in %) of Nicaragua in 2010?
Ensure brevity in your answer.  -36.52. What is the difference between the Revenue generated (in %) in Netherlands in 2007 and the Revenue generated (in %) in Nicaragua in 2010?
Give a very brief answer. -24.85. What is the difference between the Revenue generated (in %) of Middle income in 2008 and the Revenue generated (in %) of Ethiopia in 2009?
Provide a short and direct response. 22.42. What is the difference between the Revenue generated (in %) in Middle income in 2008 and the Revenue generated (in %) in Netherlands in 2009?
Ensure brevity in your answer.  6.6. What is the difference between the Revenue generated (in %) of Middle income in 2008 and the Revenue generated (in %) of Nicaragua in 2009?
Keep it short and to the point. -16.12. What is the difference between the Revenue generated (in %) of Ethiopia in 2008 and the Revenue generated (in %) of Netherlands in 2009?
Make the answer very short. -14.12. What is the difference between the Revenue generated (in %) in Ethiopia in 2008 and the Revenue generated (in %) in Nicaragua in 2009?
Provide a succinct answer. -36.84. What is the difference between the Revenue generated (in %) of Netherlands in 2008 and the Revenue generated (in %) of Nicaragua in 2009?
Provide a succinct answer. -23.21. What is the difference between the Revenue generated (in %) of Middle income in 2008 and the Revenue generated (in %) of Ethiopia in 2010?
Give a very brief answer. 24.06. What is the difference between the Revenue generated (in %) of Middle income in 2008 and the Revenue generated (in %) of Netherlands in 2010?
Provide a succinct answer. 6.3. What is the difference between the Revenue generated (in %) in Middle income in 2008 and the Revenue generated (in %) in Nicaragua in 2010?
Ensure brevity in your answer.  -18.96. What is the difference between the Revenue generated (in %) in Ethiopia in 2008 and the Revenue generated (in %) in Netherlands in 2010?
Provide a short and direct response. -14.41. What is the difference between the Revenue generated (in %) in Ethiopia in 2008 and the Revenue generated (in %) in Nicaragua in 2010?
Offer a very short reply. -39.68. What is the difference between the Revenue generated (in %) of Netherlands in 2008 and the Revenue generated (in %) of Nicaragua in 2010?
Your response must be concise. -26.04. What is the difference between the Revenue generated (in %) in Middle income in 2009 and the Revenue generated (in %) in Ethiopia in 2010?
Offer a terse response. 23.44. What is the difference between the Revenue generated (in %) of Middle income in 2009 and the Revenue generated (in %) of Netherlands in 2010?
Keep it short and to the point. 5.68. What is the difference between the Revenue generated (in %) of Middle income in 2009 and the Revenue generated (in %) of Nicaragua in 2010?
Make the answer very short. -19.59. What is the difference between the Revenue generated (in %) in Ethiopia in 2009 and the Revenue generated (in %) in Netherlands in 2010?
Provide a succinct answer. -16.11. What is the difference between the Revenue generated (in %) of Ethiopia in 2009 and the Revenue generated (in %) of Nicaragua in 2010?
Give a very brief answer. -41.38. What is the difference between the Revenue generated (in %) in Netherlands in 2009 and the Revenue generated (in %) in Nicaragua in 2010?
Your answer should be very brief. -25.56. What is the average Revenue generated (in %) of Middle income per year?
Make the answer very short. 33.68. What is the average Revenue generated (in %) of Ethiopia per year?
Keep it short and to the point. 12.29. What is the average Revenue generated (in %) in Netherlands per year?
Ensure brevity in your answer.  27.4. What is the average Revenue generated (in %) in Nicaragua per year?
Provide a succinct answer. 50.45. In the year 2003, what is the difference between the Revenue generated (in %) of Middle income and Revenue generated (in %) of Ethiopia?
Provide a succinct answer. 21.42. In the year 2003, what is the difference between the Revenue generated (in %) of Middle income and Revenue generated (in %) of Netherlands?
Ensure brevity in your answer.  5.43. In the year 2003, what is the difference between the Revenue generated (in %) of Middle income and Revenue generated (in %) of Nicaragua?
Offer a very short reply. -18.34. In the year 2003, what is the difference between the Revenue generated (in %) of Ethiopia and Revenue generated (in %) of Netherlands?
Provide a succinct answer. -15.98. In the year 2003, what is the difference between the Revenue generated (in %) in Ethiopia and Revenue generated (in %) in Nicaragua?
Make the answer very short. -39.76. In the year 2003, what is the difference between the Revenue generated (in %) of Netherlands and Revenue generated (in %) of Nicaragua?
Offer a terse response. -23.77. In the year 2004, what is the difference between the Revenue generated (in %) of Middle income and Revenue generated (in %) of Ethiopia?
Keep it short and to the point. 23.8. In the year 2004, what is the difference between the Revenue generated (in %) in Middle income and Revenue generated (in %) in Netherlands?
Your response must be concise. 5.51. In the year 2004, what is the difference between the Revenue generated (in %) of Middle income and Revenue generated (in %) of Nicaragua?
Provide a short and direct response. -16.61. In the year 2004, what is the difference between the Revenue generated (in %) of Ethiopia and Revenue generated (in %) of Netherlands?
Ensure brevity in your answer.  -18.29. In the year 2004, what is the difference between the Revenue generated (in %) in Ethiopia and Revenue generated (in %) in Nicaragua?
Offer a terse response. -40.4. In the year 2004, what is the difference between the Revenue generated (in %) of Netherlands and Revenue generated (in %) of Nicaragua?
Your response must be concise. -22.12. In the year 2005, what is the difference between the Revenue generated (in %) in Middle income and Revenue generated (in %) in Ethiopia?
Give a very brief answer. 22.94. In the year 2005, what is the difference between the Revenue generated (in %) in Middle income and Revenue generated (in %) in Netherlands?
Your response must be concise. 5.5. In the year 2005, what is the difference between the Revenue generated (in %) of Middle income and Revenue generated (in %) of Nicaragua?
Your answer should be compact. -17.05. In the year 2005, what is the difference between the Revenue generated (in %) of Ethiopia and Revenue generated (in %) of Netherlands?
Offer a very short reply. -17.44. In the year 2005, what is the difference between the Revenue generated (in %) of Ethiopia and Revenue generated (in %) of Nicaragua?
Offer a very short reply. -39.99. In the year 2005, what is the difference between the Revenue generated (in %) of Netherlands and Revenue generated (in %) of Nicaragua?
Your response must be concise. -22.55. In the year 2006, what is the difference between the Revenue generated (in %) in Middle income and Revenue generated (in %) in Ethiopia?
Your answer should be very brief. 15.57. In the year 2006, what is the difference between the Revenue generated (in %) in Middle income and Revenue generated (in %) in Netherlands?
Make the answer very short. 5.24. In the year 2006, what is the difference between the Revenue generated (in %) in Middle income and Revenue generated (in %) in Nicaragua?
Provide a succinct answer. -16.85. In the year 2006, what is the difference between the Revenue generated (in %) in Ethiopia and Revenue generated (in %) in Netherlands?
Provide a short and direct response. -10.33. In the year 2006, what is the difference between the Revenue generated (in %) in Ethiopia and Revenue generated (in %) in Nicaragua?
Offer a terse response. -32.43. In the year 2006, what is the difference between the Revenue generated (in %) in Netherlands and Revenue generated (in %) in Nicaragua?
Provide a succinct answer. -22.1. In the year 2007, what is the difference between the Revenue generated (in %) of Middle income and Revenue generated (in %) of Ethiopia?
Your answer should be compact. 17.93. In the year 2007, what is the difference between the Revenue generated (in %) in Middle income and Revenue generated (in %) in Netherlands?
Ensure brevity in your answer.  6.25. In the year 2007, what is the difference between the Revenue generated (in %) in Middle income and Revenue generated (in %) in Nicaragua?
Offer a very short reply. -15.83. In the year 2007, what is the difference between the Revenue generated (in %) in Ethiopia and Revenue generated (in %) in Netherlands?
Provide a succinct answer. -11.68. In the year 2007, what is the difference between the Revenue generated (in %) of Ethiopia and Revenue generated (in %) of Nicaragua?
Keep it short and to the point. -33.76. In the year 2007, what is the difference between the Revenue generated (in %) of Netherlands and Revenue generated (in %) of Nicaragua?
Offer a very short reply. -22.08. In the year 2008, what is the difference between the Revenue generated (in %) of Middle income and Revenue generated (in %) of Ethiopia?
Provide a short and direct response. 20.72. In the year 2008, what is the difference between the Revenue generated (in %) of Middle income and Revenue generated (in %) of Netherlands?
Keep it short and to the point. 7.08. In the year 2008, what is the difference between the Revenue generated (in %) of Middle income and Revenue generated (in %) of Nicaragua?
Ensure brevity in your answer.  -16.7. In the year 2008, what is the difference between the Revenue generated (in %) of Ethiopia and Revenue generated (in %) of Netherlands?
Give a very brief answer. -13.64. In the year 2008, what is the difference between the Revenue generated (in %) of Ethiopia and Revenue generated (in %) of Nicaragua?
Ensure brevity in your answer.  -37.42. In the year 2008, what is the difference between the Revenue generated (in %) of Netherlands and Revenue generated (in %) of Nicaragua?
Your answer should be compact. -23.79. In the year 2009, what is the difference between the Revenue generated (in %) in Middle income and Revenue generated (in %) in Ethiopia?
Provide a short and direct response. 21.79. In the year 2009, what is the difference between the Revenue generated (in %) of Middle income and Revenue generated (in %) of Netherlands?
Provide a short and direct response. 5.97. In the year 2009, what is the difference between the Revenue generated (in %) of Middle income and Revenue generated (in %) of Nicaragua?
Offer a very short reply. -16.75. In the year 2009, what is the difference between the Revenue generated (in %) of Ethiopia and Revenue generated (in %) of Netherlands?
Offer a terse response. -15.82. In the year 2009, what is the difference between the Revenue generated (in %) of Ethiopia and Revenue generated (in %) of Nicaragua?
Ensure brevity in your answer.  -38.54. In the year 2009, what is the difference between the Revenue generated (in %) in Netherlands and Revenue generated (in %) in Nicaragua?
Make the answer very short. -22.72. In the year 2010, what is the difference between the Revenue generated (in %) in Middle income and Revenue generated (in %) in Ethiopia?
Offer a terse response. 27.01. In the year 2010, what is the difference between the Revenue generated (in %) of Middle income and Revenue generated (in %) of Netherlands?
Offer a terse response. 9.25. In the year 2010, what is the difference between the Revenue generated (in %) of Middle income and Revenue generated (in %) of Nicaragua?
Provide a short and direct response. -16.01. In the year 2010, what is the difference between the Revenue generated (in %) in Ethiopia and Revenue generated (in %) in Netherlands?
Offer a terse response. -17.76. In the year 2010, what is the difference between the Revenue generated (in %) of Ethiopia and Revenue generated (in %) of Nicaragua?
Your answer should be compact. -43.02. In the year 2010, what is the difference between the Revenue generated (in %) of Netherlands and Revenue generated (in %) of Nicaragua?
Make the answer very short. -25.26. What is the ratio of the Revenue generated (in %) in Middle income in 2003 to that in 2004?
Make the answer very short. 0.99. What is the ratio of the Revenue generated (in %) of Ethiopia in 2003 to that in 2004?
Offer a terse response. 1.19. What is the ratio of the Revenue generated (in %) in Netherlands in 2003 to that in 2004?
Give a very brief answer. 0.99. What is the ratio of the Revenue generated (in %) in Nicaragua in 2003 to that in 2004?
Make the answer very short. 1.03. What is the ratio of the Revenue generated (in %) of Ethiopia in 2003 to that in 2005?
Ensure brevity in your answer.  1.13. What is the ratio of the Revenue generated (in %) of Netherlands in 2003 to that in 2005?
Ensure brevity in your answer.  1. What is the ratio of the Revenue generated (in %) in Nicaragua in 2003 to that in 2005?
Provide a succinct answer. 1.02. What is the ratio of the Revenue generated (in %) of Middle income in 2003 to that in 2006?
Provide a short and direct response. 1.03. What is the ratio of the Revenue generated (in %) of Ethiopia in 2003 to that in 2006?
Keep it short and to the point. 0.71. What is the ratio of the Revenue generated (in %) in Nicaragua in 2003 to that in 2006?
Give a very brief answer. 1.05. What is the ratio of the Revenue generated (in %) in Ethiopia in 2003 to that in 2007?
Your answer should be compact. 0.76. What is the ratio of the Revenue generated (in %) of Netherlands in 2003 to that in 2007?
Provide a succinct answer. 1.02. What is the ratio of the Revenue generated (in %) of Nicaragua in 2003 to that in 2007?
Your answer should be compact. 1.05. What is the ratio of the Revenue generated (in %) of Ethiopia in 2003 to that in 2008?
Ensure brevity in your answer.  0.96. What is the ratio of the Revenue generated (in %) in Netherlands in 2003 to that in 2008?
Provide a succinct answer. 1.07. What is the ratio of the Revenue generated (in %) in Nicaragua in 2003 to that in 2008?
Your answer should be compact. 1.04. What is the ratio of the Revenue generated (in %) of Middle income in 2003 to that in 2009?
Your answer should be compact. 1.02. What is the ratio of the Revenue generated (in %) in Ethiopia in 2003 to that in 2009?
Provide a short and direct response. 1.1. What is the ratio of the Revenue generated (in %) of Netherlands in 2003 to that in 2009?
Your answer should be compact. 1.05. What is the ratio of the Revenue generated (in %) in Nicaragua in 2003 to that in 2009?
Keep it short and to the point. 1.05. What is the ratio of the Revenue generated (in %) of Middle income in 2003 to that in 2010?
Make the answer very short. 0.92. What is the ratio of the Revenue generated (in %) of Ethiopia in 2003 to that in 2010?
Your answer should be very brief. 1.3. What is the ratio of the Revenue generated (in %) in Netherlands in 2003 to that in 2010?
Your answer should be very brief. 1.04. What is the ratio of the Revenue generated (in %) in Middle income in 2004 to that in 2005?
Your response must be concise. 1.01. What is the ratio of the Revenue generated (in %) in Ethiopia in 2004 to that in 2005?
Your response must be concise. 0.95. What is the ratio of the Revenue generated (in %) of Netherlands in 2004 to that in 2005?
Keep it short and to the point. 1.01. What is the ratio of the Revenue generated (in %) of Middle income in 2004 to that in 2006?
Provide a short and direct response. 1.04. What is the ratio of the Revenue generated (in %) of Ethiopia in 2004 to that in 2006?
Ensure brevity in your answer.  0.59. What is the ratio of the Revenue generated (in %) in Netherlands in 2004 to that in 2006?
Ensure brevity in your answer.  1.04. What is the ratio of the Revenue generated (in %) of Nicaragua in 2004 to that in 2006?
Your answer should be very brief. 1.02. What is the ratio of the Revenue generated (in %) of Ethiopia in 2004 to that in 2007?
Offer a very short reply. 0.64. What is the ratio of the Revenue generated (in %) of Netherlands in 2004 to that in 2007?
Your answer should be compact. 1.04. What is the ratio of the Revenue generated (in %) in Nicaragua in 2004 to that in 2007?
Make the answer very short. 1.02. What is the ratio of the Revenue generated (in %) of Middle income in 2004 to that in 2008?
Make the answer very short. 1.02. What is the ratio of the Revenue generated (in %) of Ethiopia in 2004 to that in 2008?
Provide a short and direct response. 0.8. What is the ratio of the Revenue generated (in %) in Netherlands in 2004 to that in 2008?
Keep it short and to the point. 1.08. What is the ratio of the Revenue generated (in %) of Middle income in 2004 to that in 2009?
Give a very brief answer. 1.04. What is the ratio of the Revenue generated (in %) in Ethiopia in 2004 to that in 2009?
Offer a very short reply. 0.93. What is the ratio of the Revenue generated (in %) of Netherlands in 2004 to that in 2009?
Keep it short and to the point. 1.06. What is the ratio of the Revenue generated (in %) in Nicaragua in 2004 to that in 2009?
Your answer should be very brief. 1.02. What is the ratio of the Revenue generated (in %) in Middle income in 2004 to that in 2010?
Your answer should be compact. 0.94. What is the ratio of the Revenue generated (in %) in Ethiopia in 2004 to that in 2010?
Give a very brief answer. 1.09. What is the ratio of the Revenue generated (in %) in Netherlands in 2004 to that in 2010?
Give a very brief answer. 1.05. What is the ratio of the Revenue generated (in %) in Nicaragua in 2004 to that in 2010?
Give a very brief answer. 0.97. What is the ratio of the Revenue generated (in %) in Middle income in 2005 to that in 2006?
Your answer should be very brief. 1.03. What is the ratio of the Revenue generated (in %) in Ethiopia in 2005 to that in 2006?
Provide a short and direct response. 0.62. What is the ratio of the Revenue generated (in %) of Netherlands in 2005 to that in 2006?
Keep it short and to the point. 1.03. What is the ratio of the Revenue generated (in %) of Nicaragua in 2005 to that in 2006?
Offer a very short reply. 1.02. What is the ratio of the Revenue generated (in %) in Middle income in 2005 to that in 2007?
Provide a short and direct response. 1. What is the ratio of the Revenue generated (in %) of Ethiopia in 2005 to that in 2007?
Make the answer very short. 0.68. What is the ratio of the Revenue generated (in %) of Netherlands in 2005 to that in 2007?
Your response must be concise. 1.02. What is the ratio of the Revenue generated (in %) in Nicaragua in 2005 to that in 2007?
Keep it short and to the point. 1.02. What is the ratio of the Revenue generated (in %) of Middle income in 2005 to that in 2008?
Ensure brevity in your answer.  1.01. What is the ratio of the Revenue generated (in %) of Ethiopia in 2005 to that in 2008?
Make the answer very short. 0.85. What is the ratio of the Revenue generated (in %) of Netherlands in 2005 to that in 2008?
Make the answer very short. 1.07. What is the ratio of the Revenue generated (in %) of Nicaragua in 2005 to that in 2008?
Your answer should be compact. 1.01. What is the ratio of the Revenue generated (in %) of Middle income in 2005 to that in 2009?
Provide a succinct answer. 1.03. What is the ratio of the Revenue generated (in %) of Ethiopia in 2005 to that in 2009?
Your answer should be compact. 0.98. What is the ratio of the Revenue generated (in %) of Netherlands in 2005 to that in 2009?
Offer a terse response. 1.05. What is the ratio of the Revenue generated (in %) in Nicaragua in 2005 to that in 2009?
Make the answer very short. 1.02. What is the ratio of the Revenue generated (in %) in Middle income in 2005 to that in 2010?
Keep it short and to the point. 0.93. What is the ratio of the Revenue generated (in %) in Ethiopia in 2005 to that in 2010?
Your response must be concise. 1.15. What is the ratio of the Revenue generated (in %) of Netherlands in 2005 to that in 2010?
Your answer should be compact. 1.04. What is the ratio of the Revenue generated (in %) in Nicaragua in 2005 to that in 2010?
Your answer should be very brief. 0.97. What is the ratio of the Revenue generated (in %) in Middle income in 2006 to that in 2007?
Your answer should be very brief. 0.97. What is the ratio of the Revenue generated (in %) of Ethiopia in 2006 to that in 2007?
Provide a short and direct response. 1.08. What is the ratio of the Revenue generated (in %) of Nicaragua in 2006 to that in 2007?
Make the answer very short. 1. What is the ratio of the Revenue generated (in %) of Middle income in 2006 to that in 2008?
Your answer should be compact. 0.98. What is the ratio of the Revenue generated (in %) in Ethiopia in 2006 to that in 2008?
Give a very brief answer. 1.35. What is the ratio of the Revenue generated (in %) in Netherlands in 2006 to that in 2008?
Ensure brevity in your answer.  1.04. What is the ratio of the Revenue generated (in %) in Nicaragua in 2006 to that in 2008?
Provide a short and direct response. 0.99. What is the ratio of the Revenue generated (in %) in Ethiopia in 2006 to that in 2009?
Keep it short and to the point. 1.57. What is the ratio of the Revenue generated (in %) in Middle income in 2006 to that in 2010?
Make the answer very short. 0.9. What is the ratio of the Revenue generated (in %) in Ethiopia in 2006 to that in 2010?
Your response must be concise. 1.84. What is the ratio of the Revenue generated (in %) in Netherlands in 2006 to that in 2010?
Make the answer very short. 1.01. What is the ratio of the Revenue generated (in %) of Nicaragua in 2006 to that in 2010?
Offer a very short reply. 0.95. What is the ratio of the Revenue generated (in %) in Middle income in 2007 to that in 2008?
Keep it short and to the point. 1.01. What is the ratio of the Revenue generated (in %) of Ethiopia in 2007 to that in 2008?
Offer a very short reply. 1.25. What is the ratio of the Revenue generated (in %) in Netherlands in 2007 to that in 2008?
Give a very brief answer. 1.05. What is the ratio of the Revenue generated (in %) in Nicaragua in 2007 to that in 2008?
Offer a very short reply. 0.99. What is the ratio of the Revenue generated (in %) of Middle income in 2007 to that in 2009?
Offer a very short reply. 1.03. What is the ratio of the Revenue generated (in %) in Ethiopia in 2007 to that in 2009?
Provide a short and direct response. 1.45. What is the ratio of the Revenue generated (in %) of Netherlands in 2007 to that in 2009?
Offer a terse response. 1.03. What is the ratio of the Revenue generated (in %) in Middle income in 2007 to that in 2010?
Your answer should be very brief. 0.93. What is the ratio of the Revenue generated (in %) in Ethiopia in 2007 to that in 2010?
Make the answer very short. 1.7. What is the ratio of the Revenue generated (in %) of Netherlands in 2007 to that in 2010?
Keep it short and to the point. 1.02. What is the ratio of the Revenue generated (in %) of Nicaragua in 2007 to that in 2010?
Provide a succinct answer. 0.95. What is the ratio of the Revenue generated (in %) in Middle income in 2008 to that in 2009?
Your response must be concise. 1.02. What is the ratio of the Revenue generated (in %) of Ethiopia in 2008 to that in 2009?
Ensure brevity in your answer.  1.16. What is the ratio of the Revenue generated (in %) in Netherlands in 2008 to that in 2009?
Your answer should be very brief. 0.98. What is the ratio of the Revenue generated (in %) in Nicaragua in 2008 to that in 2009?
Make the answer very short. 1.01. What is the ratio of the Revenue generated (in %) in Middle income in 2008 to that in 2010?
Keep it short and to the point. 0.92. What is the ratio of the Revenue generated (in %) of Ethiopia in 2008 to that in 2010?
Offer a very short reply. 1.36. What is the ratio of the Revenue generated (in %) in Netherlands in 2008 to that in 2010?
Provide a short and direct response. 0.97. What is the ratio of the Revenue generated (in %) of Nicaragua in 2008 to that in 2010?
Offer a terse response. 0.96. What is the ratio of the Revenue generated (in %) in Middle income in 2009 to that in 2010?
Your answer should be compact. 0.9. What is the ratio of the Revenue generated (in %) of Ethiopia in 2009 to that in 2010?
Provide a short and direct response. 1.18. What is the ratio of the Revenue generated (in %) of Nicaragua in 2009 to that in 2010?
Provide a succinct answer. 0.95. What is the difference between the highest and the second highest Revenue generated (in %) of Middle income?
Your answer should be compact. 2.35. What is the difference between the highest and the second highest Revenue generated (in %) in Ethiopia?
Offer a very short reply. 1.3. What is the difference between the highest and the second highest Revenue generated (in %) of Netherlands?
Offer a terse response. 0.31. What is the difference between the highest and the second highest Revenue generated (in %) in Nicaragua?
Provide a short and direct response. 0.48. What is the difference between the highest and the lowest Revenue generated (in %) in Middle income?
Your response must be concise. 3.64. What is the difference between the highest and the lowest Revenue generated (in %) of Ethiopia?
Ensure brevity in your answer.  7.8. What is the difference between the highest and the lowest Revenue generated (in %) in Netherlands?
Offer a terse response. 2.17. What is the difference between the highest and the lowest Revenue generated (in %) of Nicaragua?
Offer a very short reply. 2.84. 